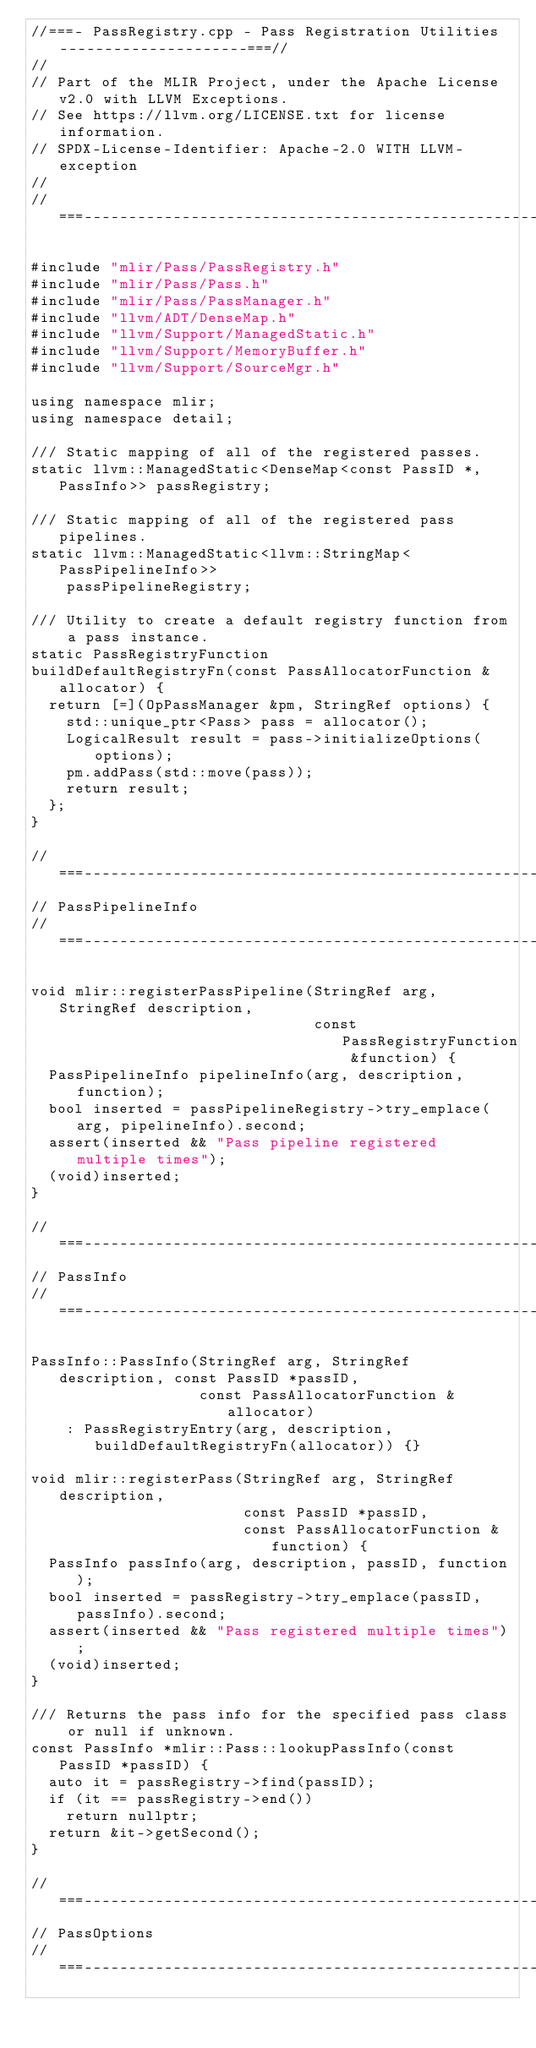<code> <loc_0><loc_0><loc_500><loc_500><_C++_>//===- PassRegistry.cpp - Pass Registration Utilities ---------------------===//
//
// Part of the MLIR Project, under the Apache License v2.0 with LLVM Exceptions.
// See https://llvm.org/LICENSE.txt for license information.
// SPDX-License-Identifier: Apache-2.0 WITH LLVM-exception
//
//===----------------------------------------------------------------------===//

#include "mlir/Pass/PassRegistry.h"
#include "mlir/Pass/Pass.h"
#include "mlir/Pass/PassManager.h"
#include "llvm/ADT/DenseMap.h"
#include "llvm/Support/ManagedStatic.h"
#include "llvm/Support/MemoryBuffer.h"
#include "llvm/Support/SourceMgr.h"

using namespace mlir;
using namespace detail;

/// Static mapping of all of the registered passes.
static llvm::ManagedStatic<DenseMap<const PassID *, PassInfo>> passRegistry;

/// Static mapping of all of the registered pass pipelines.
static llvm::ManagedStatic<llvm::StringMap<PassPipelineInfo>>
    passPipelineRegistry;

/// Utility to create a default registry function from a pass instance.
static PassRegistryFunction
buildDefaultRegistryFn(const PassAllocatorFunction &allocator) {
  return [=](OpPassManager &pm, StringRef options) {
    std::unique_ptr<Pass> pass = allocator();
    LogicalResult result = pass->initializeOptions(options);
    pm.addPass(std::move(pass));
    return result;
  };
}

//===----------------------------------------------------------------------===//
// PassPipelineInfo
//===----------------------------------------------------------------------===//

void mlir::registerPassPipeline(StringRef arg, StringRef description,
                                const PassRegistryFunction &function) {
  PassPipelineInfo pipelineInfo(arg, description, function);
  bool inserted = passPipelineRegistry->try_emplace(arg, pipelineInfo).second;
  assert(inserted && "Pass pipeline registered multiple times");
  (void)inserted;
}

//===----------------------------------------------------------------------===//
// PassInfo
//===----------------------------------------------------------------------===//

PassInfo::PassInfo(StringRef arg, StringRef description, const PassID *passID,
                   const PassAllocatorFunction &allocator)
    : PassRegistryEntry(arg, description, buildDefaultRegistryFn(allocator)) {}

void mlir::registerPass(StringRef arg, StringRef description,
                        const PassID *passID,
                        const PassAllocatorFunction &function) {
  PassInfo passInfo(arg, description, passID, function);
  bool inserted = passRegistry->try_emplace(passID, passInfo).second;
  assert(inserted && "Pass registered multiple times");
  (void)inserted;
}

/// Returns the pass info for the specified pass class or null if unknown.
const PassInfo *mlir::Pass::lookupPassInfo(const PassID *passID) {
  auto it = passRegistry->find(passID);
  if (it == passRegistry->end())
    return nullptr;
  return &it->getSecond();
}

//===----------------------------------------------------------------------===//
// PassOptions
//===----------------------------------------------------------------------===//
</code> 